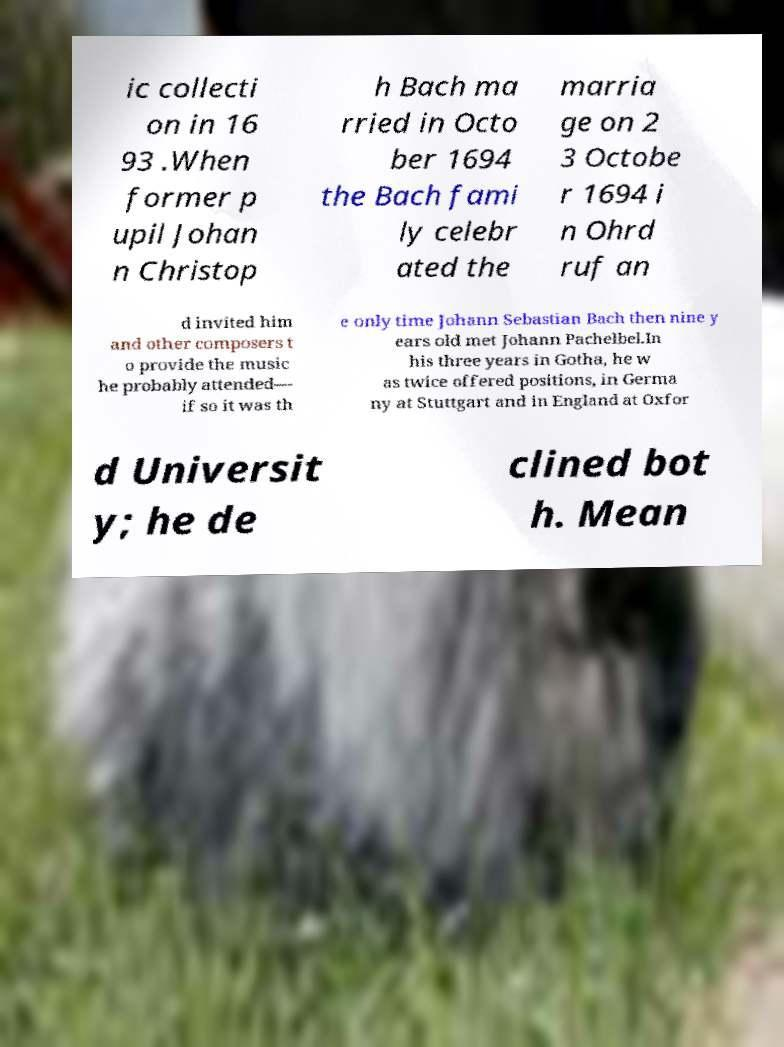I need the written content from this picture converted into text. Can you do that? ic collecti on in 16 93 .When former p upil Johan n Christop h Bach ma rried in Octo ber 1694 the Bach fami ly celebr ated the marria ge on 2 3 Octobe r 1694 i n Ohrd ruf an d invited him and other composers t o provide the music he probably attended— if so it was th e only time Johann Sebastian Bach then nine y ears old met Johann Pachelbel.In his three years in Gotha, he w as twice offered positions, in Germa ny at Stuttgart and in England at Oxfor d Universit y; he de clined bot h. Mean 